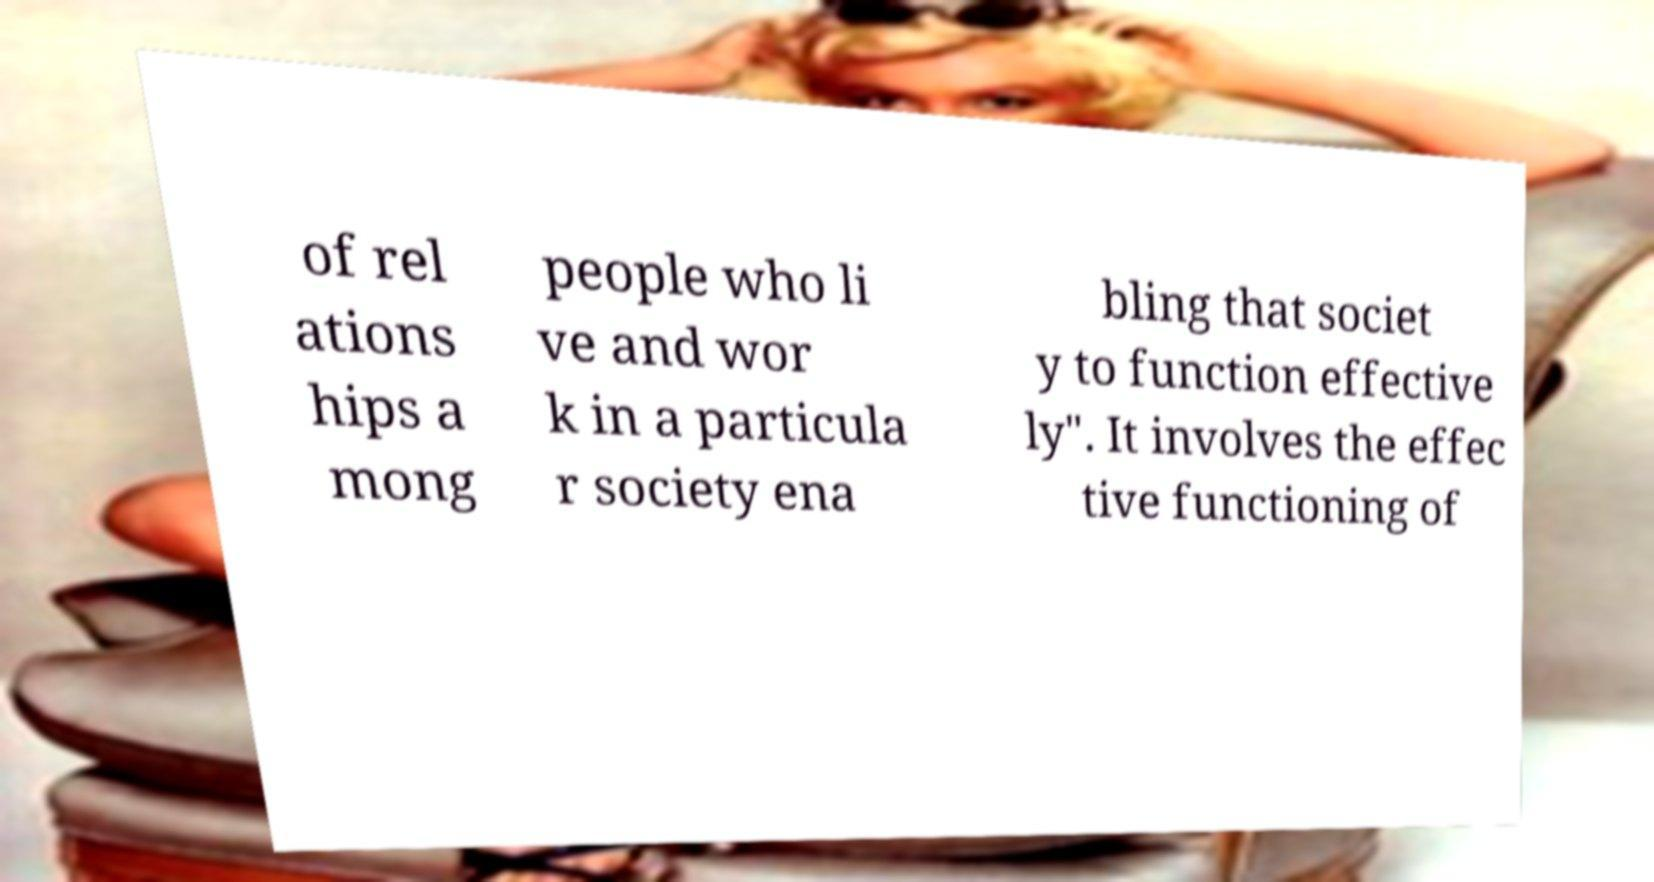What messages or text are displayed in this image? I need them in a readable, typed format. of rel ations hips a mong people who li ve and wor k in a particula r society ena bling that societ y to function effective ly". It involves the effec tive functioning of 